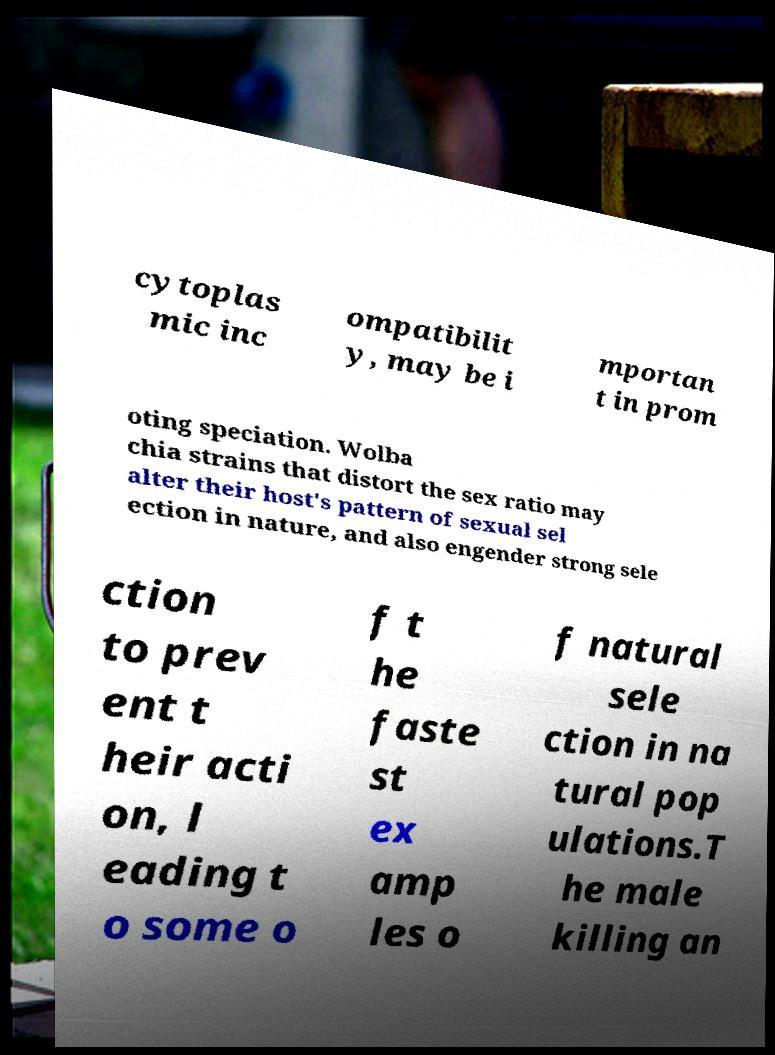I need the written content from this picture converted into text. Can you do that? cytoplas mic inc ompatibilit y, may be i mportan t in prom oting speciation. Wolba chia strains that distort the sex ratio may alter their host's pattern of sexual sel ection in nature, and also engender strong sele ction to prev ent t heir acti on, l eading t o some o f t he faste st ex amp les o f natural sele ction in na tural pop ulations.T he male killing an 